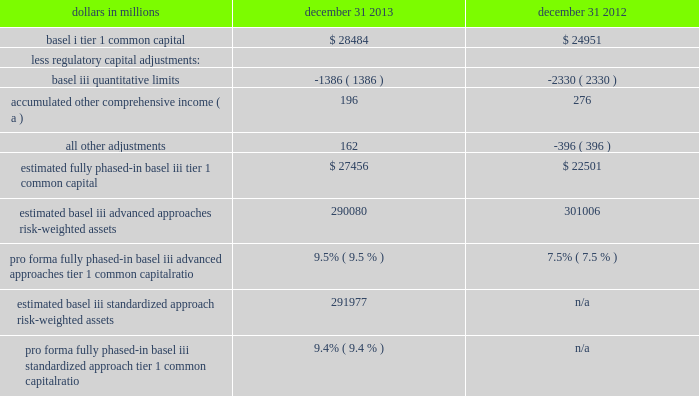Bank holding companies and banks must have basel i capital ratios of at least 6% ( 6 % ) for tier 1 risk-based , 10% ( 10 % ) for total risk- based , and 5% ( 5 % ) for leverage .
The basel ii framework , which was adopted by the basel committee on banking supervision in 2004 , seeks to provide more risk-sensitive regulatory capital calculations and promote enhanced risk management practices among large , internationally active banking organizations .
The u.s .
Banking agencies initially adopted rules to implement the basel ii capital framework in 2004 .
In july 2013 , the u.s .
Banking agencies adopted final rules ( referred to as the advanced approaches ) that modified the basel ii framework effective january 1 , 2014 .
See item 1 business 2013 supervision and regulation and item 1a risk factors in this report .
Prior to fully implementing the advanced approaches established by these rules to calculate risk-weighted assets , pnc and pnc bank , n.a .
Must successfully complete a 201cparallel run 201d qualification phase .
Both pnc and pnc bank , n.a .
Entered this parallel run phase under the basel ii capital framework on january 1 , 2013 .
This phase must last at least four consecutive quarters , although , consistent with the experience of other u.s .
Banks , we currently anticipate a multi-year parallel run period .
In july 2013 , the u.s .
Banking agencies also adopted final rules that : ( i ) materially modify the definition of , and required deductions from , regulatory capital ( referred to as the basel iii rule ) ; and ( ii ) revise the framework for the risk-weighting of assets under basel i ( referred to as the standardized approach ) .
The basel iii rule became effective for pnc on january 1 , 2014 , although many of its provisions are phased-in over a period of years , with the rules generally becoming fully effective on january 1 , 2019 .
The standardized approach rule becomes effective on january 1 , 2015 .
Tier 1 common capital as defined under the basel iii rule differs materially from basel i .
For example , under basel iii , significant common stock investments in unconsolidated financial institutions , mortgage servicing rights and deferred tax assets must be deducted from capital to the extent they individually exceed 10% ( 10 % ) , or in the aggregate exceed 15% ( 15 % ) , of the institution 2019s adjusted tier 1 common capital .
Also , basel i regulatory capital excludes other comprehensive income related to both available for sale securities and pension and other postretirement plans , whereas under basel iii these items are a component of pnc 2019s capital .
The basel iii final rule also eliminates the tier 1 treatment of trust preferred securities for bank holding companies with $ 15 billion or more in assets .
In the third quarter of 2013 , we concluded our redemptions of the discounted trust preferred securities assumed through acquisitions .
See item 1 business- supervision and regulation and note 14 capital securities of subsidiary trusts and perpetual trust securities in the notes to consolidated financial statements in item 8 of this report for additional discussion of our previous redemptions of trust preferred securities .
We provide information below regarding pnc 2019s pro forma fully phased-in basel iii tier 1 common capital ratio under both the advanced approaches and standardized approach frameworks and how it differs from the basel i tier 1 common capital ratios shown in table 18 above .
After pnc exits parallel run , its regulatory basel iii risk-based capital ratios will be the lower of the ratios as calculated under the standardized and advanced approaches .
Table 19 : estimated pro forma fully phased-in basel iii tier 1 common capital ratio dollars in millions december 31 december 31 .
Estimated fully phased-in basel iii tier 1 common capital $ 27456 $ 22501 estimated basel iii advanced approaches risk-weighted assets 290080 301006 pro forma fully phased-in basel iii advanced approaches tier 1 common capital ratio 9.5% ( 9.5 % ) 7.5% ( 7.5 % ) estimated basel iii standardized approach risk-weighted assets 291977 n/a pro forma fully phased-in basel iii standardized approach tier 1 common capital ratio 9.4% ( 9.4 % ) n/a ( a ) represents net adjustments related to accumulated other comprehensive income for available for sale securities and pension and other postretirement benefit plans .
Basel iii advanced approaches risk-weighted assets were estimated based on the advanced approaches rules and application of basel ii.5 , and reflect credit , market and operational risk .
Basel iii standardized approach risk- weighted assets were estimated based on the standardized approach rules and reflect credit and market risk .
As a result of the staggered effective dates of the final u.s .
Capital rules issued in july 2013 , as well as the fact that pnc remains in the parallel run qualification phase for the advanced approaches , pnc 2019s regulatory risk-based capital ratios in 2014 will be based on the definitions of , and deductions from , capital under basel iii ( as such definitions and deductions are phased-in for 2014 ) and basel i risk- weighted assets ( but subject to certain adjustments as defined by the basel iii rules ) .
We refer to the capital ratios calculated using these basel iii phased-in provisions and basel i risk- weighted assets as the transitional basel iii ratios .
We provide in the table below a pro forma illustration of the basel iii transitional tier i common capital ratio using december 31 , 2013 data and the basel iii phase-in schedule in effect for 2014 .
The pnc financial services group , inc .
2013 form 10-k 47 .
In 2013 what was the ratio of the basel iii tier 1 common capital to the basel i tier 1 common capital? 
Computations: (27456 / 28484)
Answer: 0.96391. 